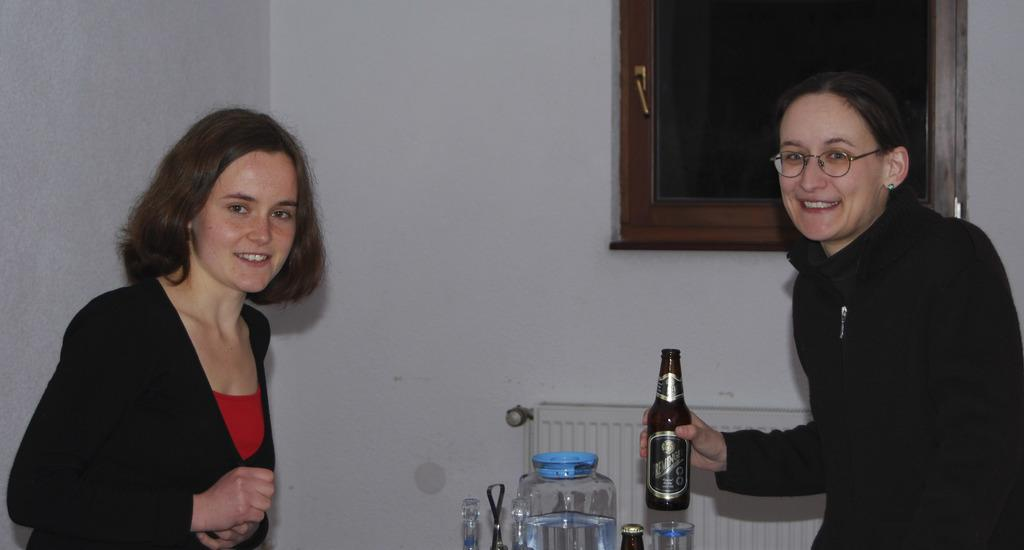How many women are in the image? There are two women in the image. What are the women doing in the image? Both women are standing. Can you describe the actions of one of the women? One woman is holding a bottle and smiling. What objects can be seen in the image besides the women? There is a jar, a bottle, a glass, a window with a door, and a jar in the image. What are the women wearing in the image? Both women are wearing black jackets. What type of trucks can be seen in the image? There are no trucks present in the image. What is the texture of the room in the image? The image does not show a room, so it is not possible to determine the texture of the room. 